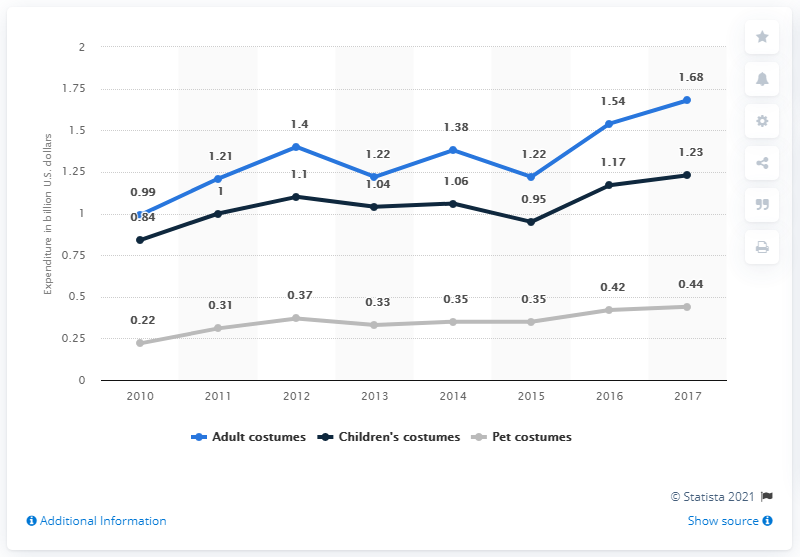Outline some significant characteristics in this image. In 2017, adult consumers spent an average of $1.68 on Halloween costumes. 